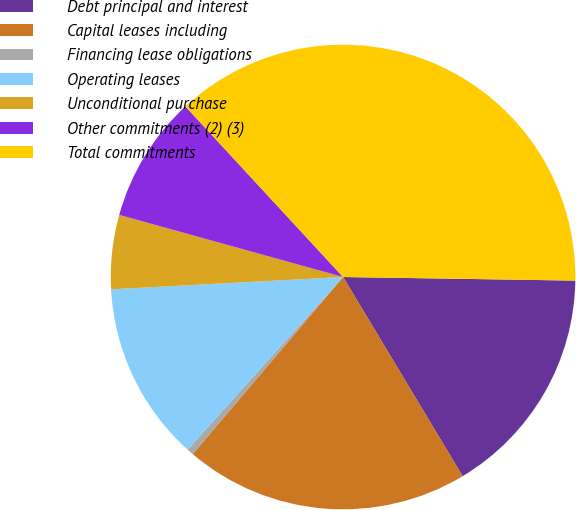Convert chart to OTSL. <chart><loc_0><loc_0><loc_500><loc_500><pie_chart><fcel>Debt principal and interest<fcel>Capital leases including<fcel>Financing lease obligations<fcel>Operating leases<fcel>Unconditional purchase<fcel>Other commitments (2) (3)<fcel>Total commitments<nl><fcel>16.15%<fcel>19.81%<fcel>0.47%<fcel>12.48%<fcel>5.15%<fcel>8.82%<fcel>37.12%<nl></chart> 